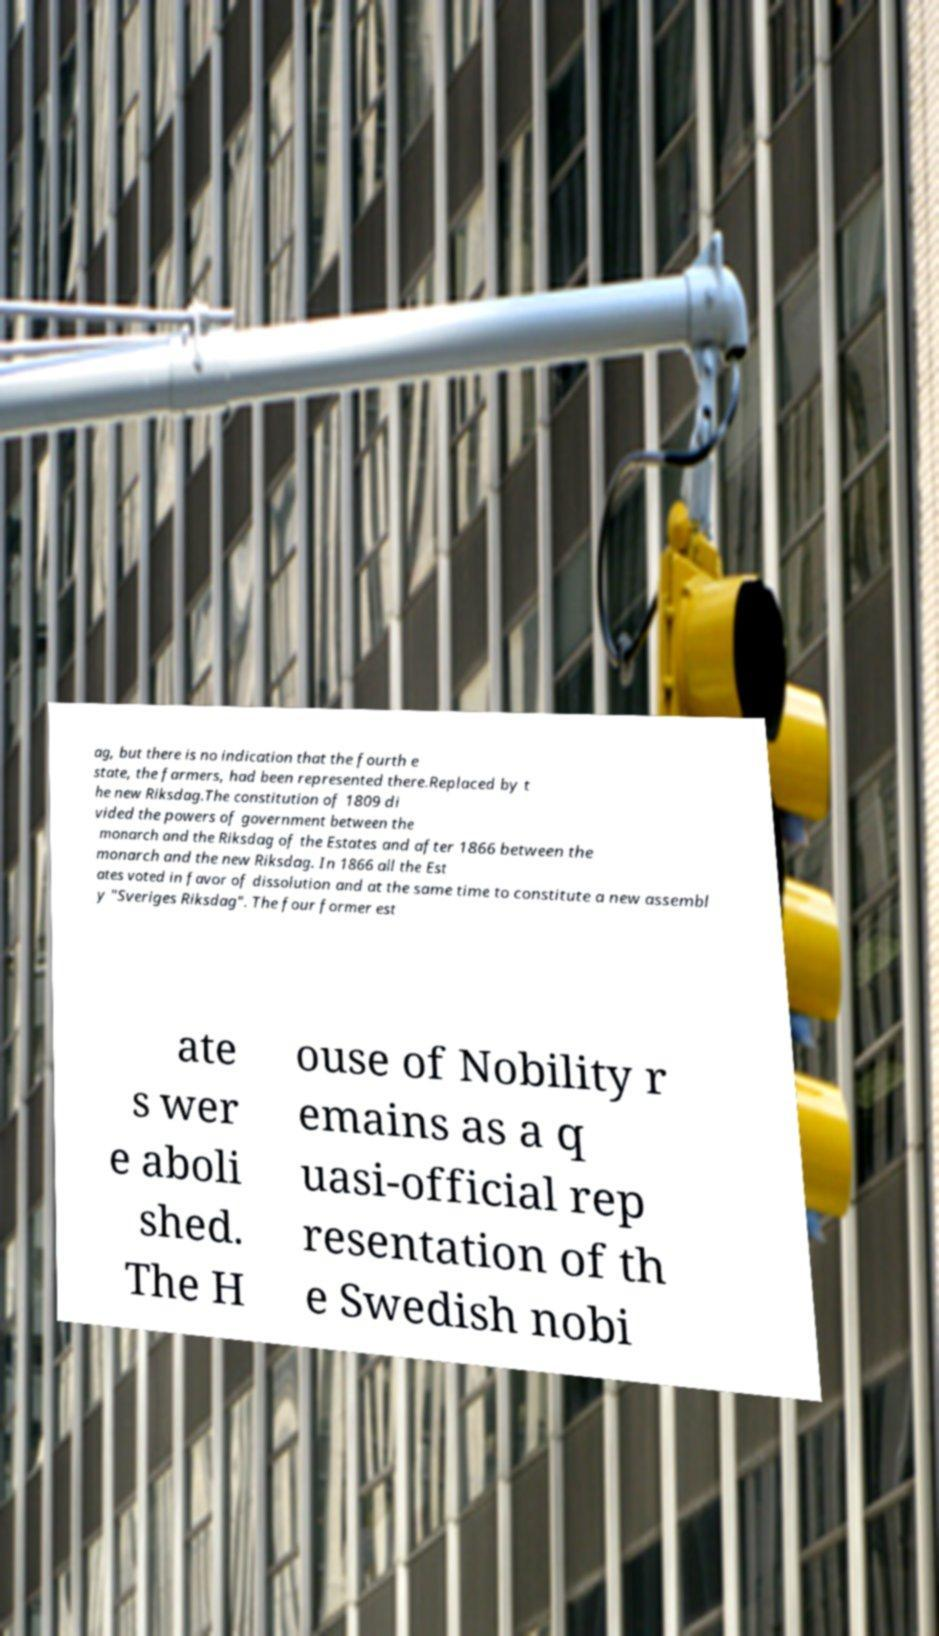Please identify and transcribe the text found in this image. ag, but there is no indication that the fourth e state, the farmers, had been represented there.Replaced by t he new Riksdag.The constitution of 1809 di vided the powers of government between the monarch and the Riksdag of the Estates and after 1866 between the monarch and the new Riksdag. In 1866 all the Est ates voted in favor of dissolution and at the same time to constitute a new assembl y "Sveriges Riksdag". The four former est ate s wer e aboli shed. The H ouse of Nobility r emains as a q uasi-official rep resentation of th e Swedish nobi 